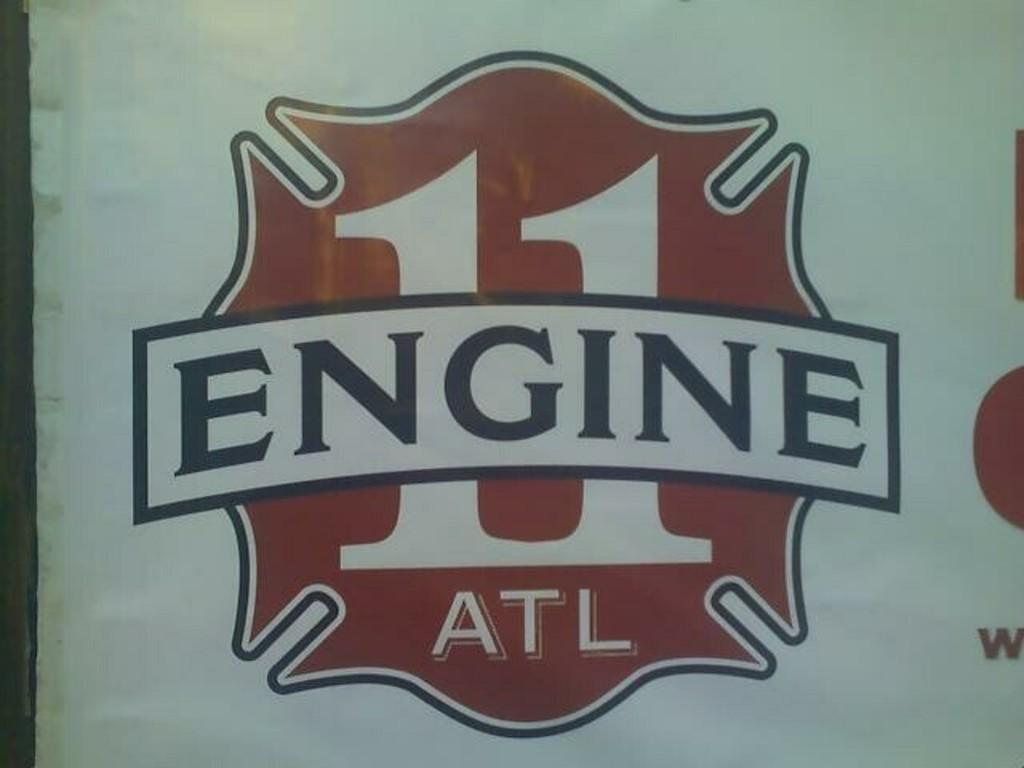<image>
Share a concise interpretation of the image provided. The emblem for Atlanta's Engine company 11 is mostly red on a white background. 